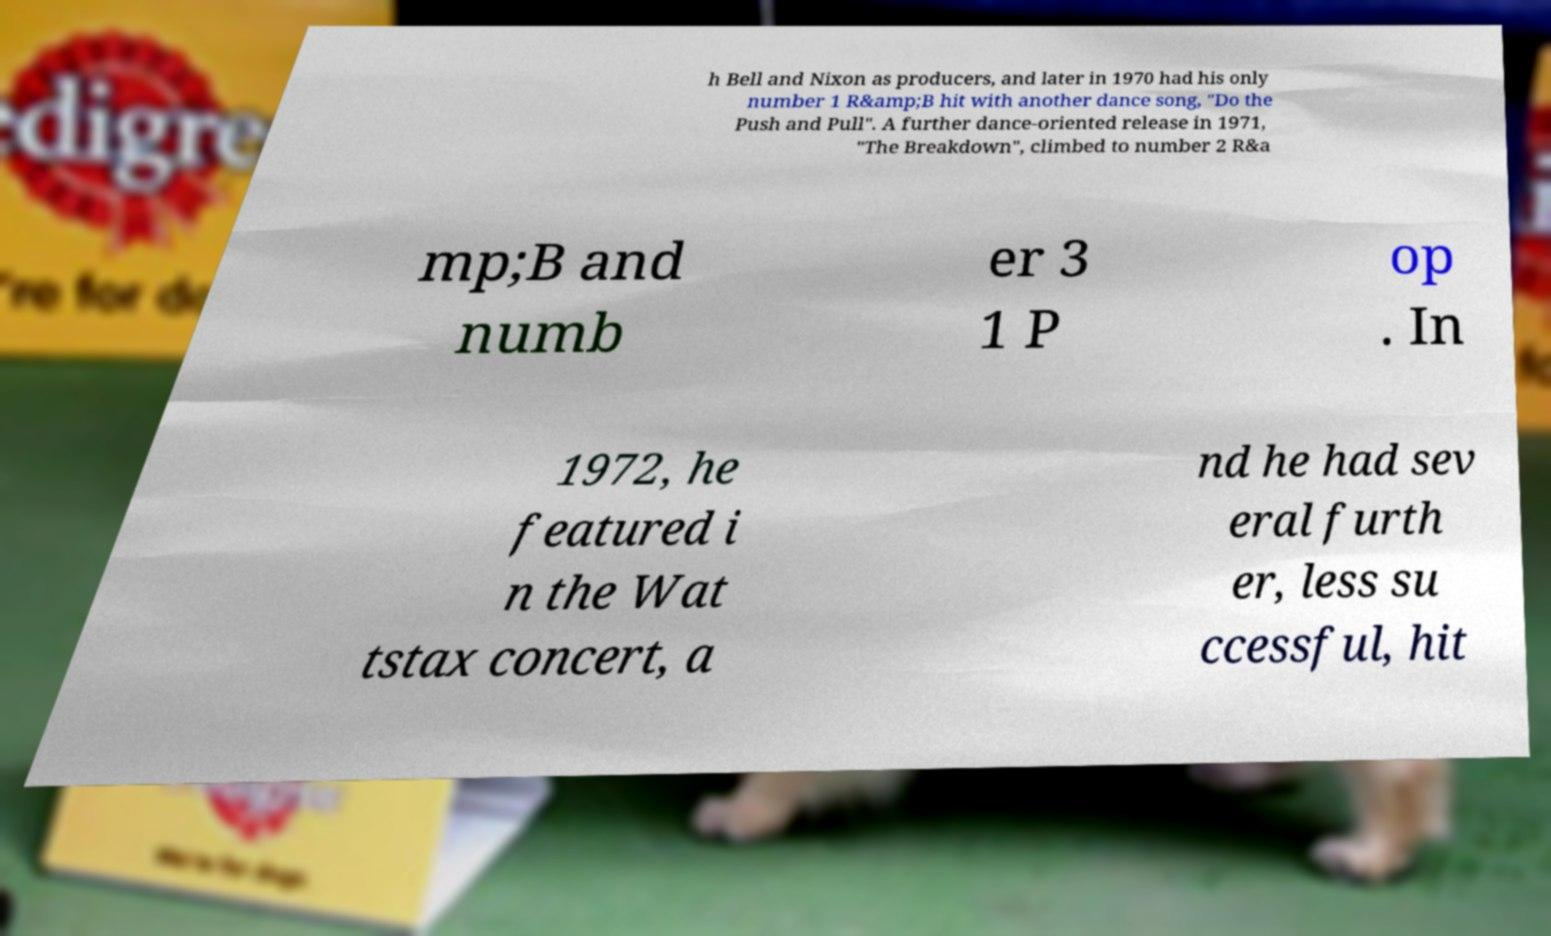Please read and relay the text visible in this image. What does it say? h Bell and Nixon as producers, and later in 1970 had his only number 1 R&amp;B hit with another dance song, "Do the Push and Pull". A further dance-oriented release in 1971, "The Breakdown", climbed to number 2 R&a mp;B and numb er 3 1 P op . In 1972, he featured i n the Wat tstax concert, a nd he had sev eral furth er, less su ccessful, hit 